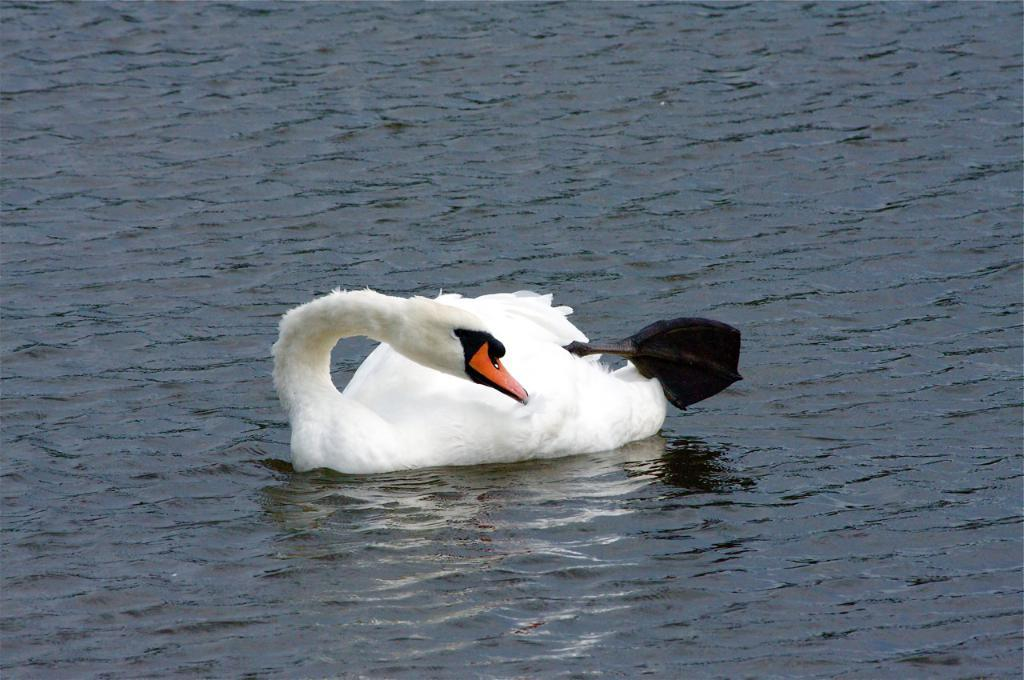What type of animal is in the image? There is a white swan in the image. Where is the swan located? The swan is on the water. What type of fruit is the swan holding in the image? There is no fruit present in the image, and the swan is not holding anything. 